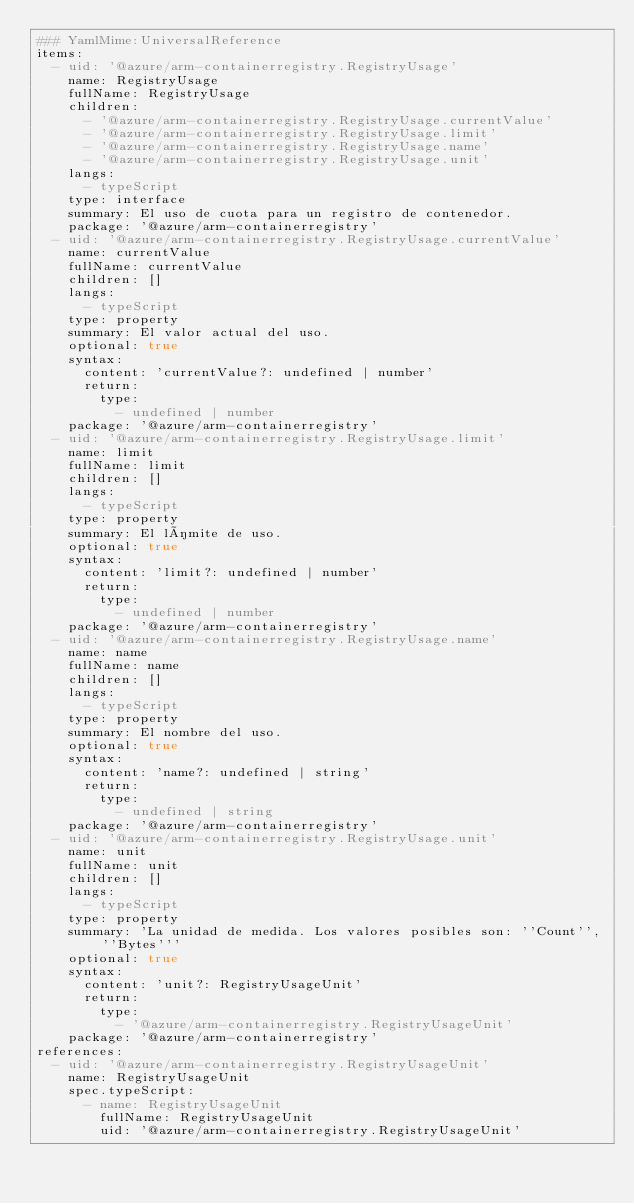Convert code to text. <code><loc_0><loc_0><loc_500><loc_500><_YAML_>### YamlMime:UniversalReference
items:
  - uid: '@azure/arm-containerregistry.RegistryUsage'
    name: RegistryUsage
    fullName: RegistryUsage
    children:
      - '@azure/arm-containerregistry.RegistryUsage.currentValue'
      - '@azure/arm-containerregistry.RegistryUsage.limit'
      - '@azure/arm-containerregistry.RegistryUsage.name'
      - '@azure/arm-containerregistry.RegistryUsage.unit'
    langs:
      - typeScript
    type: interface
    summary: El uso de cuota para un registro de contenedor.
    package: '@azure/arm-containerregistry'
  - uid: '@azure/arm-containerregistry.RegistryUsage.currentValue'
    name: currentValue
    fullName: currentValue
    children: []
    langs:
      - typeScript
    type: property
    summary: El valor actual del uso.
    optional: true
    syntax:
      content: 'currentValue?: undefined | number'
      return:
        type:
          - undefined | number
    package: '@azure/arm-containerregistry'
  - uid: '@azure/arm-containerregistry.RegistryUsage.limit'
    name: limit
    fullName: limit
    children: []
    langs:
      - typeScript
    type: property
    summary: El límite de uso.
    optional: true
    syntax:
      content: 'limit?: undefined | number'
      return:
        type:
          - undefined | number
    package: '@azure/arm-containerregistry'
  - uid: '@azure/arm-containerregistry.RegistryUsage.name'
    name: name
    fullName: name
    children: []
    langs:
      - typeScript
    type: property
    summary: El nombre del uso.
    optional: true
    syntax:
      content: 'name?: undefined | string'
      return:
        type:
          - undefined | string
    package: '@azure/arm-containerregistry'
  - uid: '@azure/arm-containerregistry.RegistryUsage.unit'
    name: unit
    fullName: unit
    children: []
    langs:
      - typeScript
    type: property
    summary: 'La unidad de medida. Los valores posibles son: ''Count'', ''Bytes'''
    optional: true
    syntax:
      content: 'unit?: RegistryUsageUnit'
      return:
        type:
          - '@azure/arm-containerregistry.RegistryUsageUnit'
    package: '@azure/arm-containerregistry'
references:
  - uid: '@azure/arm-containerregistry.RegistryUsageUnit'
    name: RegistryUsageUnit
    spec.typeScript:
      - name: RegistryUsageUnit
        fullName: RegistryUsageUnit
        uid: '@azure/arm-containerregistry.RegistryUsageUnit'</code> 